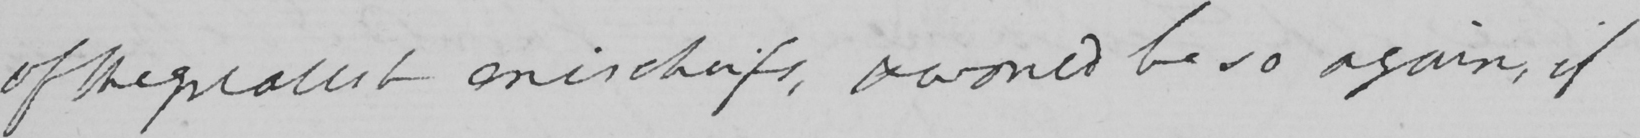What text is written in this handwritten line? of the greatest mischiefs , & would be so again , if 